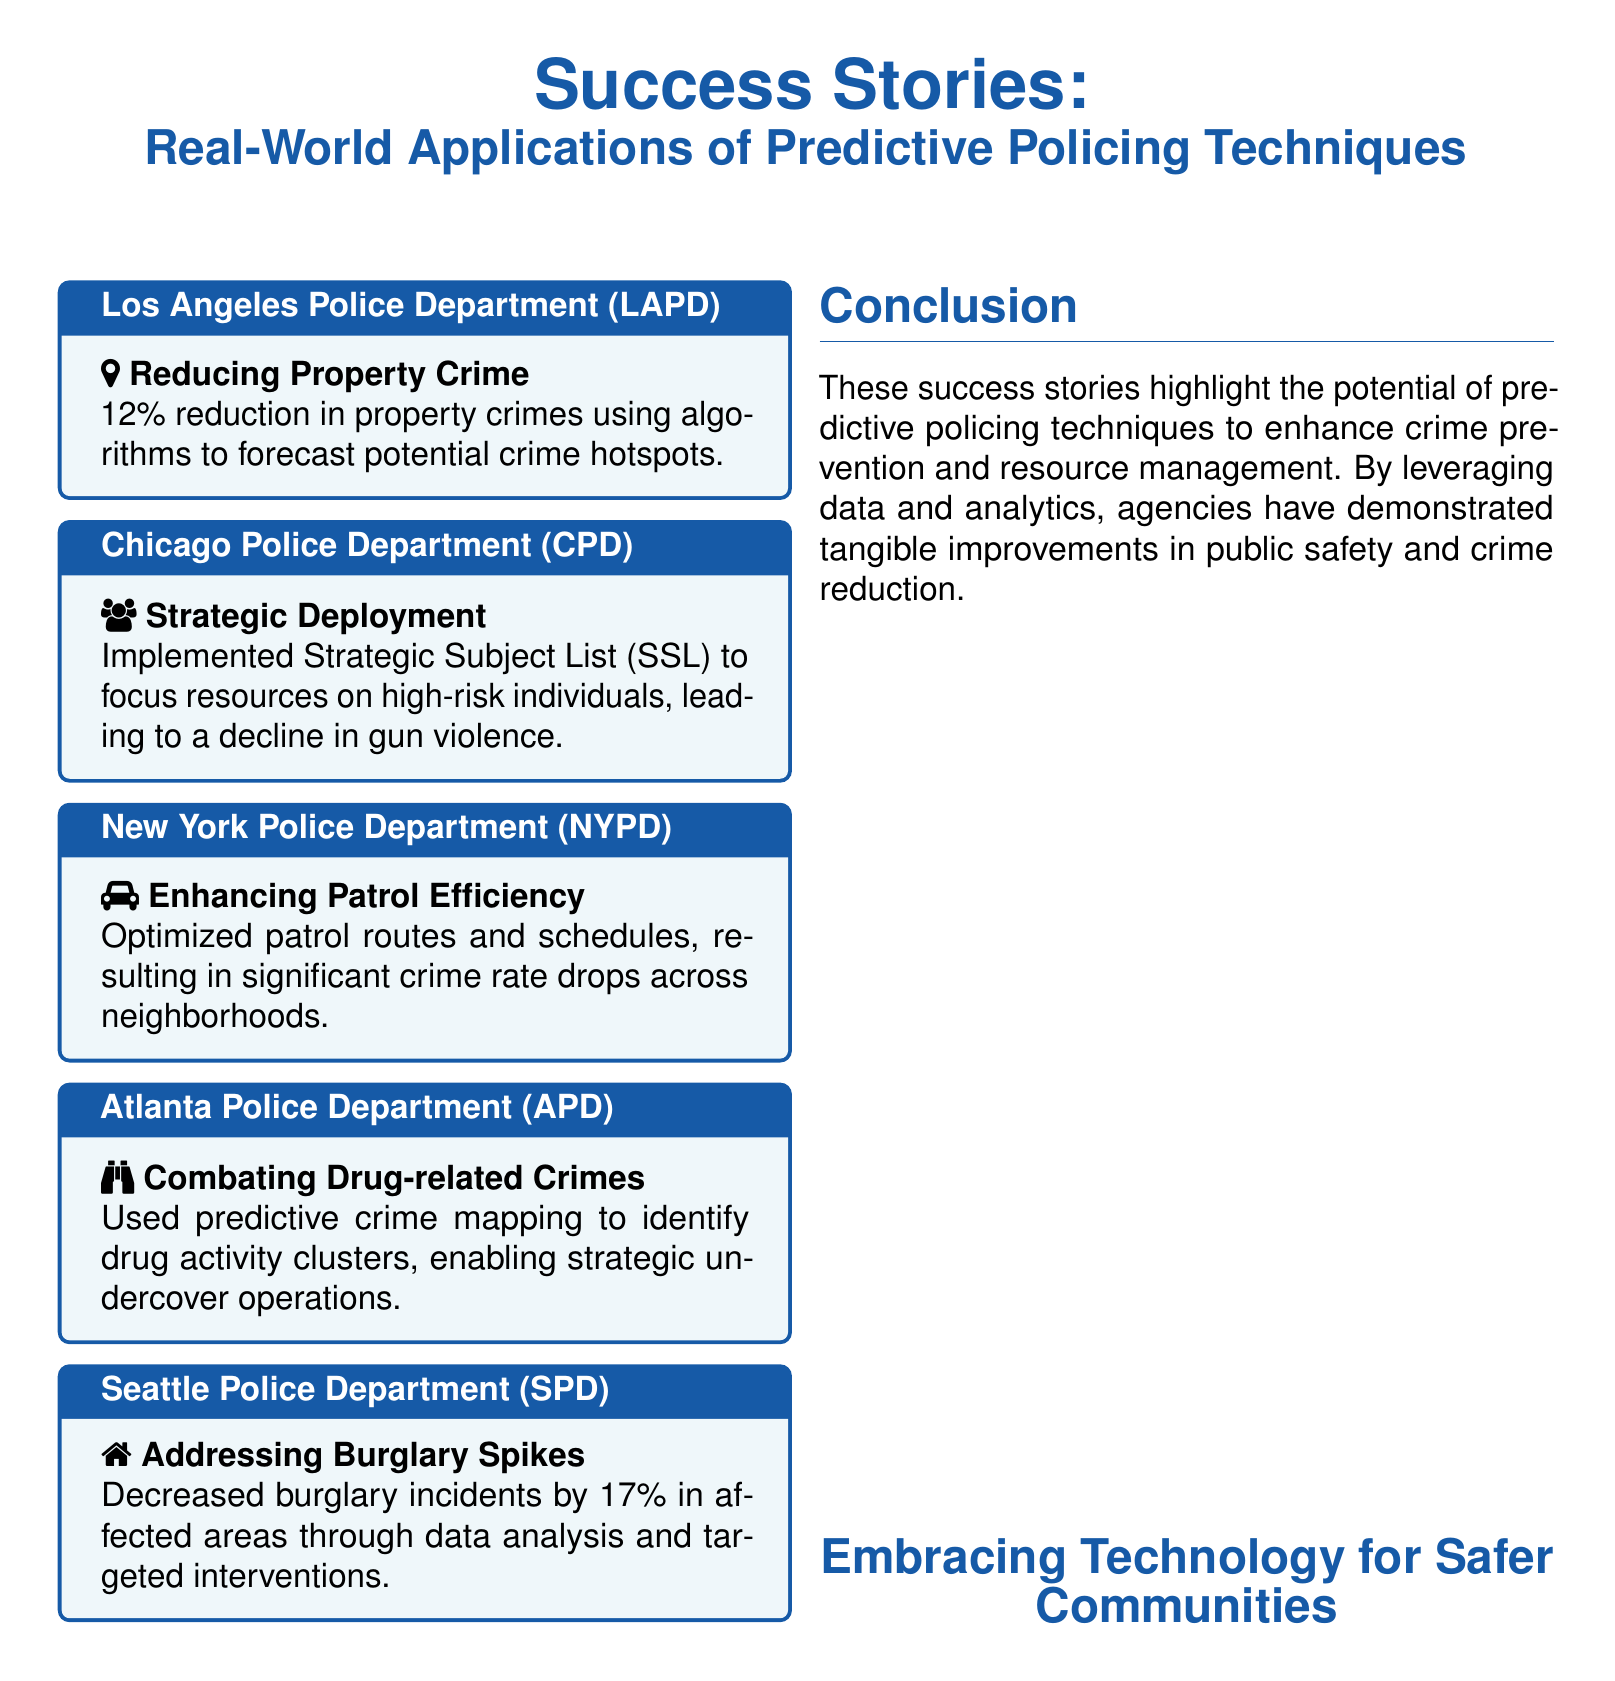what reduction in property crimes was achieved by LAPD? The document states that LAPD achieved a 12% reduction in property crimes.
Answer: 12% what technique did the Chicago Police Department implement? The document mentions that CPD implemented a Strategic Subject List (SSL).
Answer: Strategic Subject List (SSL) which police department reduced burglary incidents by 17%? The document specifies that the Seattle Police Department reduced burglary incidents by 17%.
Answer: Seattle Police Department what was one outcome of the NYPD's patrol optimization? The document notes that optimizing patrol routes and schedules led to significant crime rate drops.
Answer: significant crime rate drops how did the Atlanta Police Department combat drug-related crimes? According to the document, APD used predictive crime mapping to identify drug activity clusters.
Answer: predictive crime mapping what was the main focus of LAPD's predictive policing technique? The main focus was to forecast potential crime hotspots to reduce property crime.
Answer: forecast potential crime hotspots which technology is emphasized as beneficial for safer communities? The document highlights the importance of embracing technology for enhancing safety in communities.
Answer: embracing technology what specific area did the Seattle Police Department address with their interventions? SPD focused on addressing burglary spikes in affected areas.
Answer: burglary spikes 